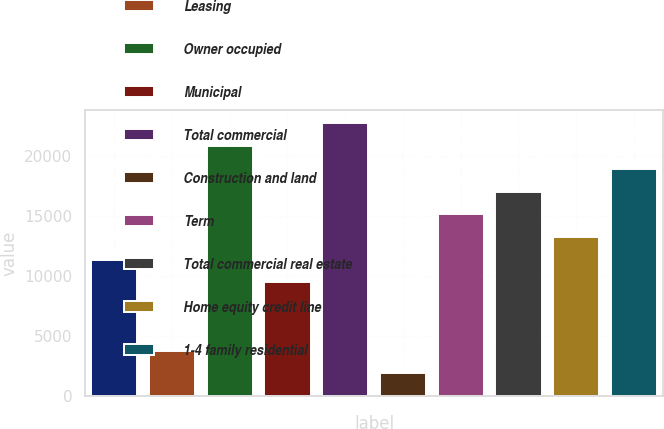Convert chart to OTSL. <chart><loc_0><loc_0><loc_500><loc_500><bar_chart><fcel>Commercial and industrial<fcel>Leasing<fcel>Owner occupied<fcel>Municipal<fcel>Total commercial<fcel>Construction and land<fcel>Term<fcel>Total commercial real estate<fcel>Home equity credit line<fcel>1-4 family residential<nl><fcel>11367.6<fcel>3805.2<fcel>20820.6<fcel>9477<fcel>22711.2<fcel>1914.6<fcel>15148.8<fcel>17039.4<fcel>13258.2<fcel>18930<nl></chart> 